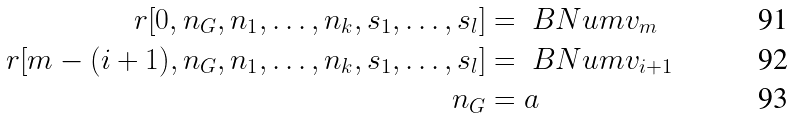<formula> <loc_0><loc_0><loc_500><loc_500>r [ 0 , n _ { G } , n _ { 1 } , \dots , n _ { k } , s _ { 1 } , \dots , s _ { l } ] & = \ B N u m { v _ { m } } \\ r [ m - ( i + 1 ) , n _ { G } , n _ { 1 } , \dots , n _ { k } , s _ { 1 } , \dots , s _ { l } ] & = \ B N u m { v _ { i + 1 } } \\ n _ { G } & = a</formula> 